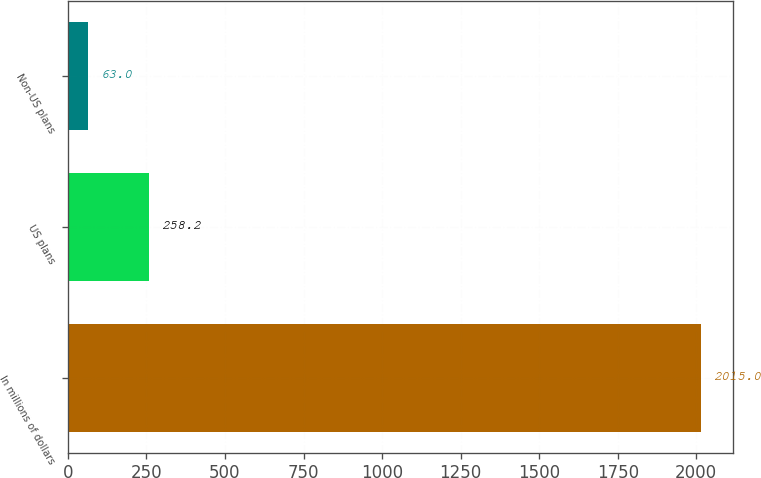Convert chart to OTSL. <chart><loc_0><loc_0><loc_500><loc_500><bar_chart><fcel>In millions of dollars<fcel>US plans<fcel>Non-US plans<nl><fcel>2015<fcel>258.2<fcel>63<nl></chart> 